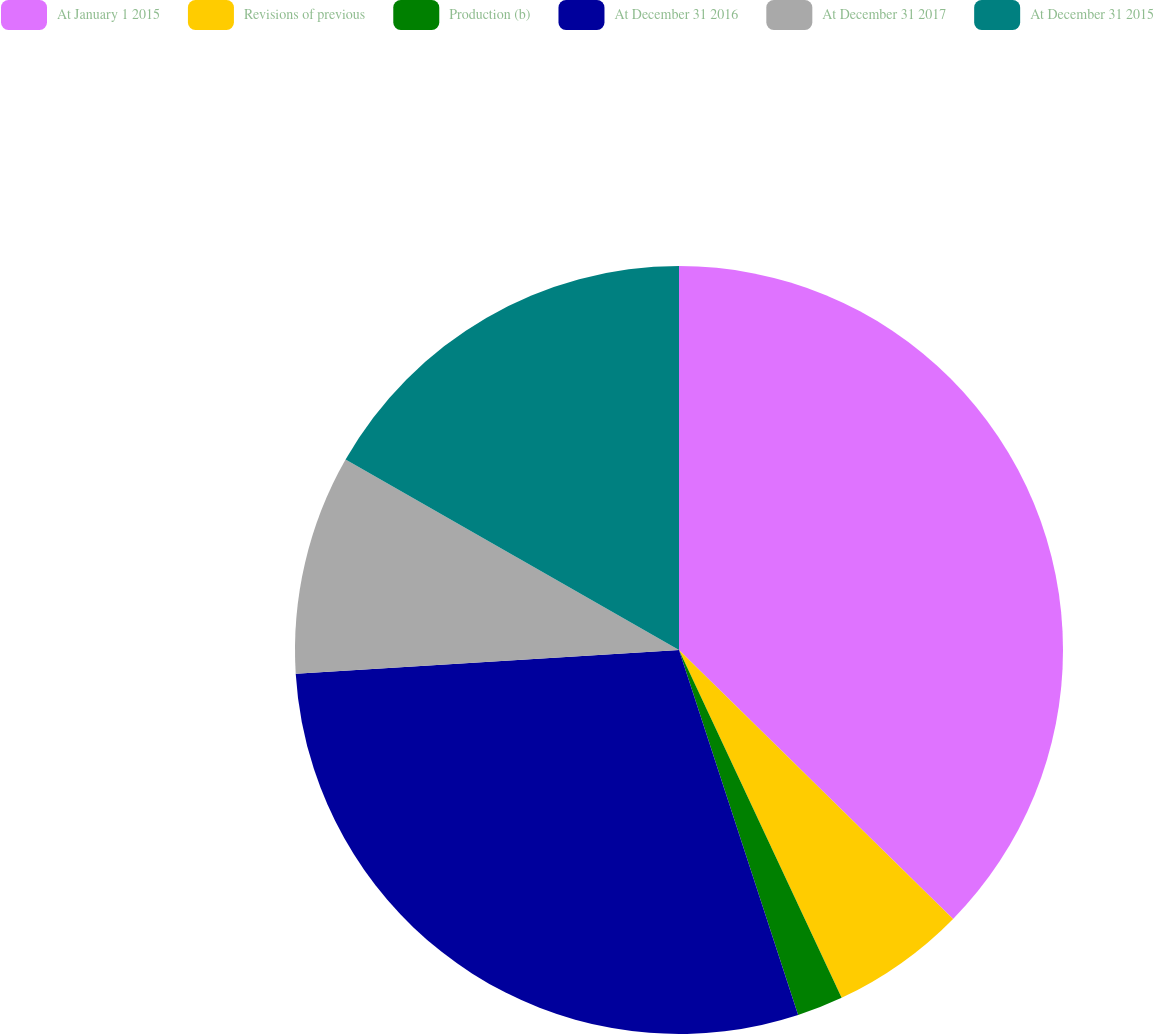Convert chart to OTSL. <chart><loc_0><loc_0><loc_500><loc_500><pie_chart><fcel>At January 1 2015<fcel>Revisions of previous<fcel>Production (b)<fcel>At December 31 2016<fcel>At December 31 2017<fcel>At December 31 2015<nl><fcel>37.35%<fcel>5.69%<fcel>1.94%<fcel>29.04%<fcel>9.24%<fcel>16.74%<nl></chart> 